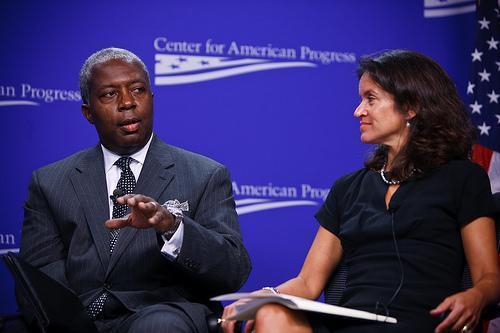How many people?
Give a very brief answer. 2. 